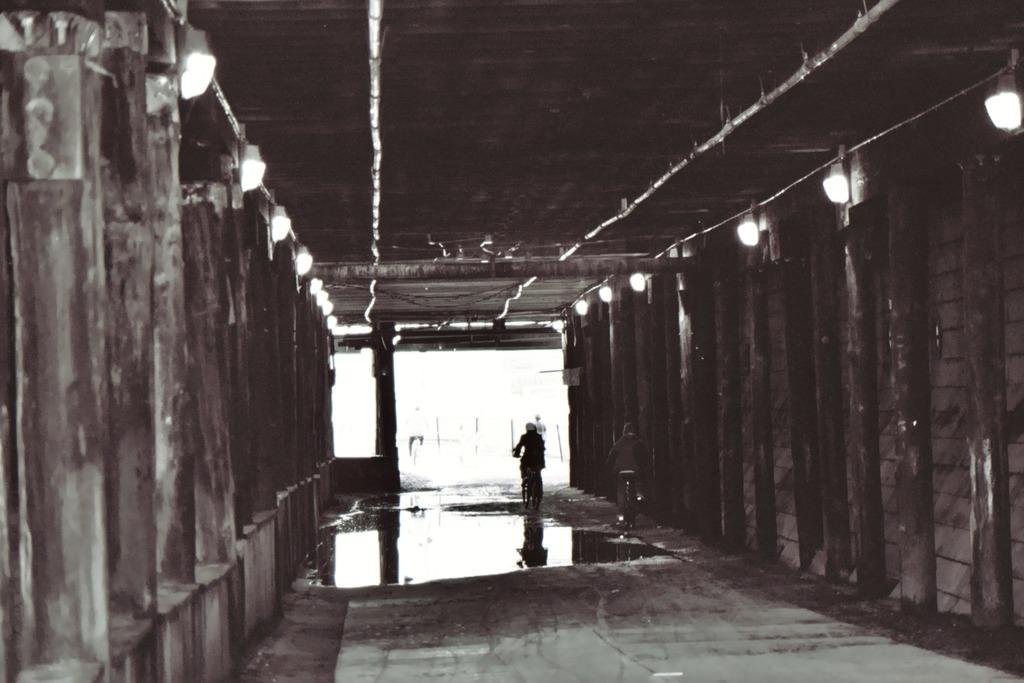What are the two persons in the image doing? The two persons in the image are riding bicycles. What can be seen on the left side of the image? There is a wooden fence on the left side of the image. What can be seen on the right side of the image? There is a wooden fence on the right side of the image. What is attached to the wooden fences? Lights are attached to the wooden fences. What type of rings can be seen on the bicycles in the image? There are no rings visible on the bicycles in the image. 